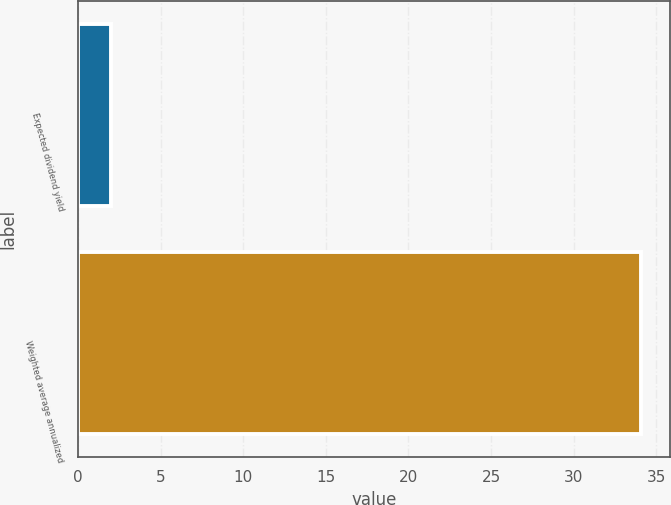Convert chart to OTSL. <chart><loc_0><loc_0><loc_500><loc_500><bar_chart><fcel>Expected dividend yield<fcel>Weighted average annualized<nl><fcel>2<fcel>34.1<nl></chart> 